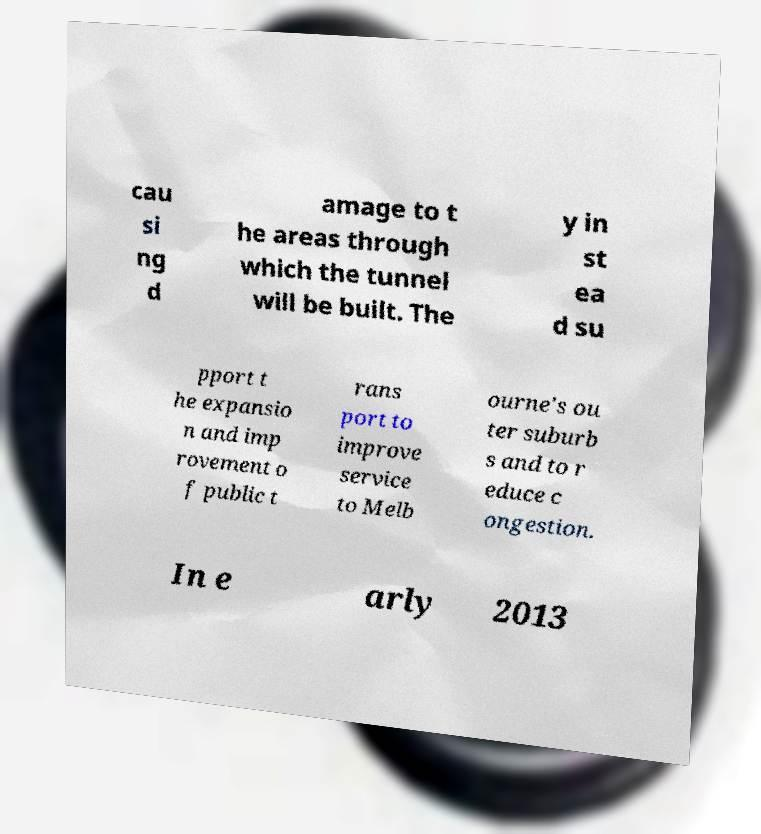There's text embedded in this image that I need extracted. Can you transcribe it verbatim? cau si ng d amage to t he areas through which the tunnel will be built. The y in st ea d su pport t he expansio n and imp rovement o f public t rans port to improve service to Melb ourne's ou ter suburb s and to r educe c ongestion. In e arly 2013 